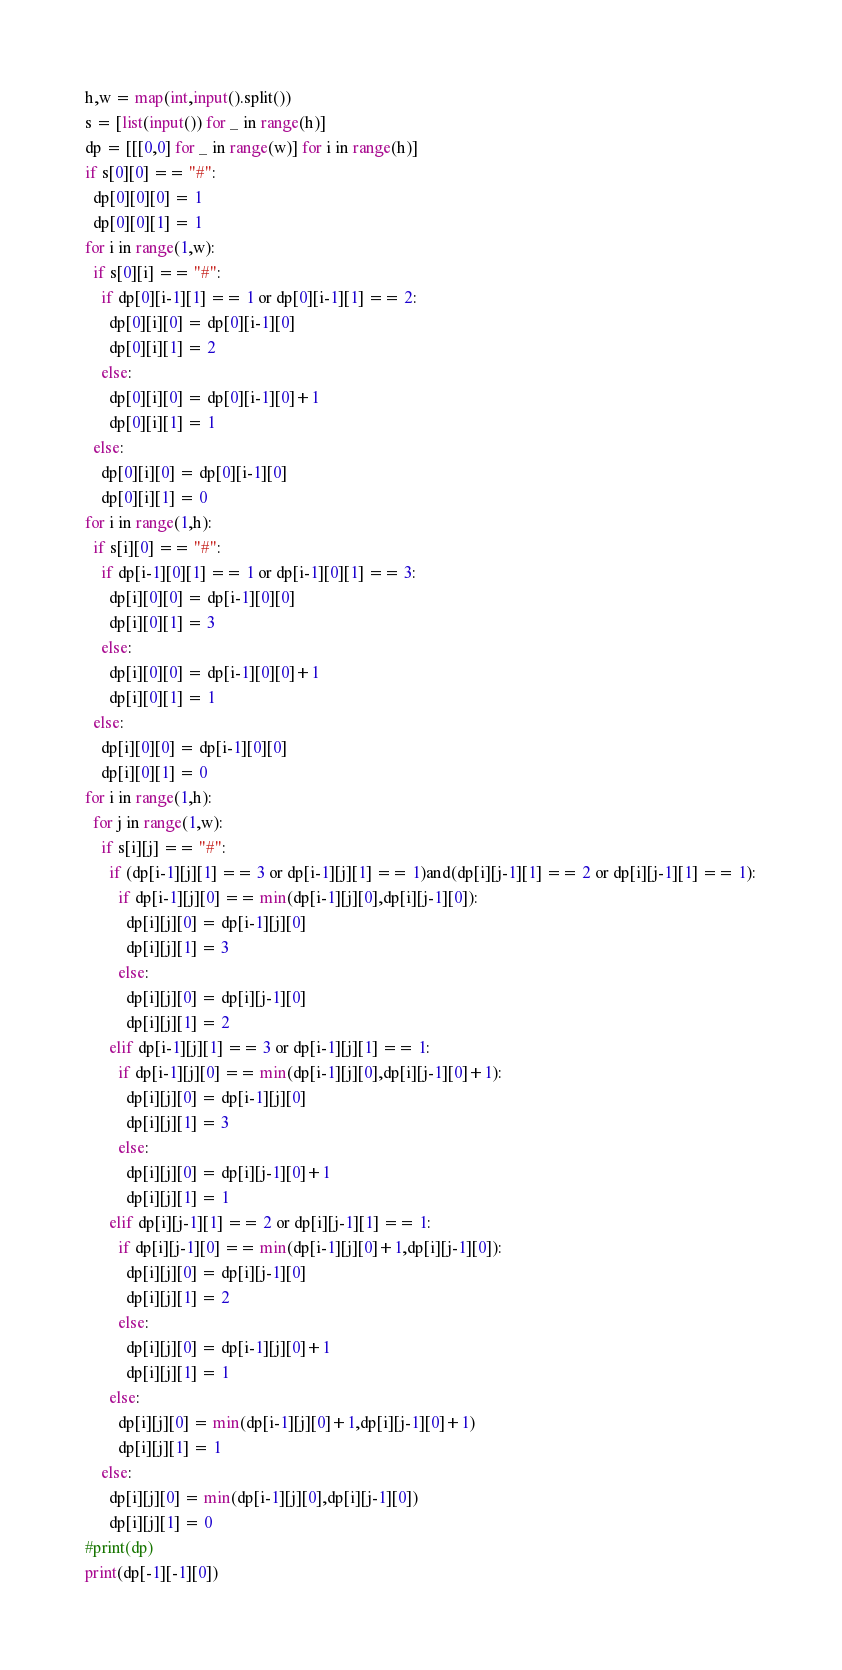Convert code to text. <code><loc_0><loc_0><loc_500><loc_500><_Python_>h,w = map(int,input().split())
s = [list(input()) for _ in range(h)]
dp = [[[0,0] for _ in range(w)] for i in range(h)]
if s[0][0] == "#":
  dp[0][0][0] = 1
  dp[0][0][1] = 1
for i in range(1,w):
  if s[0][i] == "#":
    if dp[0][i-1][1] == 1 or dp[0][i-1][1] == 2:
      dp[0][i][0] = dp[0][i-1][0]
      dp[0][i][1] = 2
    else:
      dp[0][i][0] = dp[0][i-1][0]+1
      dp[0][i][1] = 1
  else:
    dp[0][i][0] = dp[0][i-1][0]
    dp[0][i][1] = 0
for i in range(1,h):
  if s[i][0] == "#":
    if dp[i-1][0][1] == 1 or dp[i-1][0][1] == 3:
      dp[i][0][0] = dp[i-1][0][0]
      dp[i][0][1] = 3
    else:
      dp[i][0][0] = dp[i-1][0][0]+1
      dp[i][0][1] = 1
  else:
    dp[i][0][0] = dp[i-1][0][0]
    dp[i][0][1] = 0
for i in range(1,h):
  for j in range(1,w):
    if s[i][j] == "#":
      if (dp[i-1][j][1] == 3 or dp[i-1][j][1] == 1)and(dp[i][j-1][1] == 2 or dp[i][j-1][1] == 1):
        if dp[i-1][j][0] == min(dp[i-1][j][0],dp[i][j-1][0]):
          dp[i][j][0] = dp[i-1][j][0]
          dp[i][j][1] = 3
        else:
          dp[i][j][0] = dp[i][j-1][0]
          dp[i][j][1] = 2
      elif dp[i-1][j][1] == 3 or dp[i-1][j][1] == 1:
        if dp[i-1][j][0] == min(dp[i-1][j][0],dp[i][j-1][0]+1):
          dp[i][j][0] = dp[i-1][j][0]
          dp[i][j][1] = 3
        else:
          dp[i][j][0] = dp[i][j-1][0]+1
          dp[i][j][1] = 1
      elif dp[i][j-1][1] == 2 or dp[i][j-1][1] == 1:
        if dp[i][j-1][0] == min(dp[i-1][j][0]+1,dp[i][j-1][0]):
          dp[i][j][0] = dp[i][j-1][0]
          dp[i][j][1] = 2
        else:
          dp[i][j][0] = dp[i-1][j][0]+1
          dp[i][j][1] = 1
      else:
        dp[i][j][0] = min(dp[i-1][j][0]+1,dp[i][j-1][0]+1)
        dp[i][j][1] = 1
    else:
      dp[i][j][0] = min(dp[i-1][j][0],dp[i][j-1][0])
      dp[i][j][1] = 0
#print(dp)
print(dp[-1][-1][0])</code> 